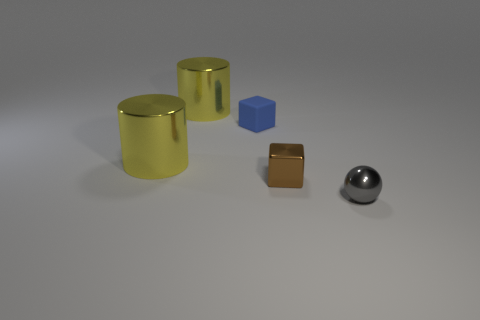Add 1 small brown blocks. How many objects exist? 6 Add 4 small shiny cubes. How many small shiny cubes exist? 5 Subtract 0 blue cylinders. How many objects are left? 5 Subtract all cylinders. How many objects are left? 3 Subtract all yellow metal things. Subtract all small brown metallic objects. How many objects are left? 2 Add 1 gray things. How many gray things are left? 2 